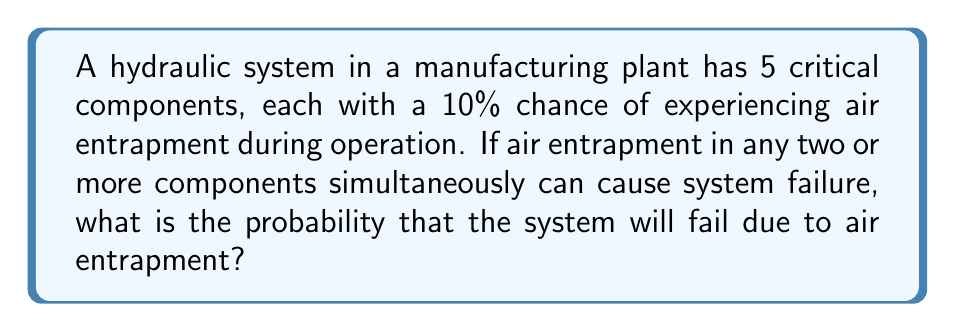Show me your answer to this math problem. Let's approach this step-by-step:

1) First, we need to calculate the probability of the system not failing. This occurs when either no components have air entrapment, or exactly one component has air entrapment.

2) The probability of a single component not having air entrapment is 90% or 0.9.

3) The probability of all 5 components not having air entrapment is:

   $$P(\text{no air entrapment}) = 0.9^5 = 0.59049$$

4) The probability of exactly one component having air entrapment can be calculated using the binomial probability formula:

   $$P(\text{exactly one}) = \binom{5}{1} \cdot 0.1 \cdot 0.9^4 = 5 \cdot 0.1 \cdot 0.6561 = 0.32805$$

5) The total probability of the system not failing is the sum of these two probabilities:

   $$P(\text{not failing}) = 0.59049 + 0.32805 = 0.91854$$

6) Therefore, the probability of the system failing is the complement of this:

   $$P(\text{failing}) = 1 - 0.91854 = 0.08146$$

Thus, there is approximately an 8.15% chance that the system will fail due to air entrapment in two or more components.
Answer: The probability that the system will fail due to air entrapment is approximately 0.08146 or 8.15%. 